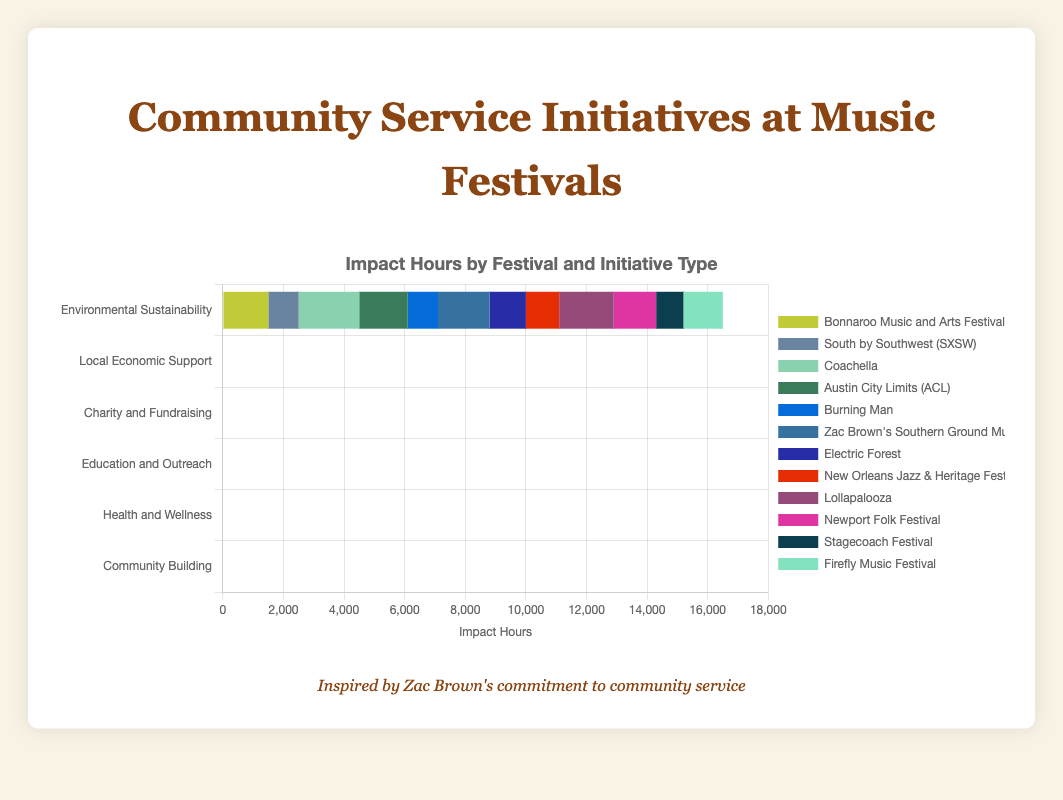What type of community service initiative had the highest total impact hours? To find the type with the highest total impact hours, sum the impact hours of both festivals for each type and then compare. Environmental Sustainability (1500+1200=2700), Local Economic Support (1000+1100=2100), Charity and Fundraising (2000+1800=3800), Education and Outreach (1600+1400=3000), Health and Wellness (1000+900=1900), Community Building (1700+1300=3000). Charity and Fundraising has the highest total impact hours.
Answer: Charity and Fundraising Which festival contributed the most impact hours towards Education and Outreach initiatives? Compare the impact hours for "Austin City Limits (ACL)" and "Newport Folk Festival" within the Education and Outreach category. ACL has 1600 impact hours, and Newport Folk Festival has 1400. Therefore, ACL contributed the most impact hours.
Answer: Austin City Limits (ACL) How do the total impact hours of Environmental Sustainability initiatives compare to Health and Wellness initiatives? Sum the impact hours for each type and then compare. Environmental Sustainability: 1500 (Bonnaroo) + 1200 (Electric Forest) = 2700 hours. Health and Wellness: 1000 (Burning Man) + 900 (Stagecoach) = 1900 hours. Environmental Sustainability initiatives have more impact hours.
Answer: Environmental Sustainability has more impact hours What is the difference in impact hours between the highest and lowest contributing festivals? Identify the highest and lowest contributing festivals by their impact hours. Highest: Coachella (2000 hours). Lowest: Stagecoach Festival (900 hours). Calculate the difference: 2000 - 900 = 1100 hours.
Answer: 1100 hours Which festival's community service initiatives focus on Local Economic Support? Refer to the Local Economic Support section and note the festivals listed. The initiatives within this category are done by "South by Southwest (SXSW)" and "New Orleans Jazz & Heritage Festival."
Answer: South by Southwest (SXSW) and New Orleans Jazz & Heritage Festival What visual marker distinguishes the "Zac Brown's Southern Ground Music & Food Festival" community building initiatives? Look at the horizontal stacked bar labeled for Community Building and identify "Zac Brown's Southern Ground Music & Food Festival" by its color. The color is unique and visually separates it from other festivals.
Answer: Its unique color How many more impact hours did Coachella contribute compared to Stagecoach Festival? Compare Coachella's impact hours (2000) with Stagecoach Festival's (900), then subtract Stagecoach's hours from Coachella's: 2000 - 900 = 1100 hours.
Answer: 1100 hours Which initiatives have an equal total impact and what types of initiatives are they? Sum the impact hours for each type and identify any types with equal totals. Education and Outreach (1600+1400 = 3000) and Community Building (1700+1300 = 3000) both total 3000 hours. They are Education and Outreach and Community Building.
Answer: Education and Outreach and Community Building What is the length of the bar representing the "Bonnaroo Music and Arts Festival" in Environmental Sustainability? Identify the "Bonnaroo Music and Arts Festival" in the Environmental Sustainability category and measure its bar length to determine its representation of 1500 impact hours.
Answer: Represents 1500 impact hours 